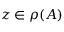<formula> <loc_0><loc_0><loc_500><loc_500>z \in \rho ( A )</formula> 